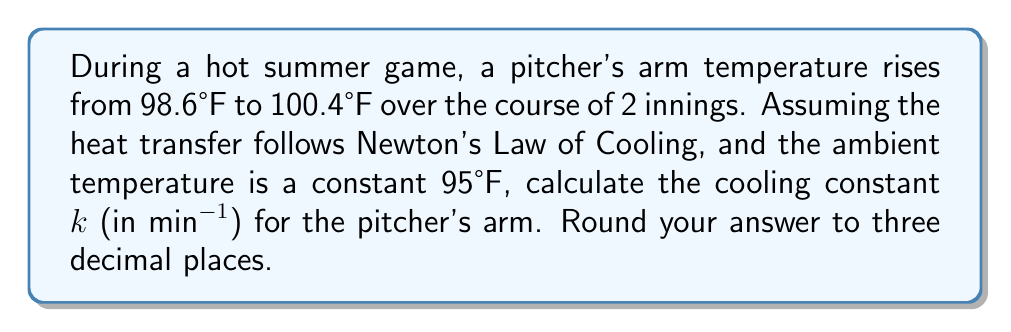Teach me how to tackle this problem. Let's approach this step-by-step using Newton's Law of Cooling:

1) Newton's Law of Cooling is given by:
   $$\frac{dT}{dt} = -k(T - T_a)$$
   where T is the temperature of the object, T_a is the ambient temperature, and k is the cooling constant.

2) The solution to this differential equation is:
   $$T(t) = T_a + (T_0 - T_a)e^{-kt}$$
   where T_0 is the initial temperature.

3) Given:
   - Initial temperature, T_0 = 98.6°F
   - Final temperature, T(t) = 100.4°F
   - Ambient temperature, T_a = 95°F
   - Time, t = 2 innings = 2 * 20 minutes = 40 minutes (assuming average inning length)

4) Substituting into the equation:
   $$100.4 = 95 + (98.6 - 95)e^{-k(40)}$$

5) Simplifying:
   $$5.4 = 3.6e^{-40k}$$

6) Dividing both sides by 3.6:
   $$1.5 = e^{-40k}$$

7) Taking natural log of both sides:
   $$\ln(1.5) = -40k$$

8) Solving for k:
   $$k = -\frac{\ln(1.5)}{40} \approx 0.0101 \text{ min}^{-1}$$

9) Rounding to three decimal places:
   $$k \approx 0.010 \text{ min}^{-1}$$
Answer: 0.010 min^(-1) 